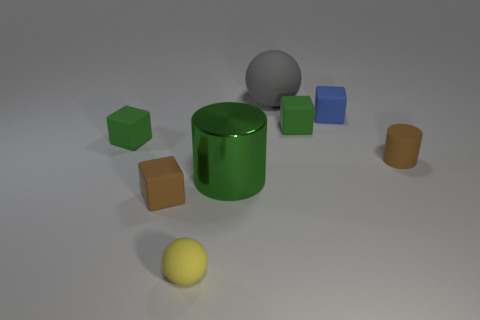Are there any other things that are the same shape as the tiny yellow object?
Your answer should be compact. Yes. How many green rubber objects are right of the big metal thing and left of the brown block?
Give a very brief answer. 0. Does the blue rubber block have the same size as the gray matte thing?
Provide a succinct answer. No. There is a green matte cube that is on the right side of the yellow rubber sphere; does it have the same size as the gray rubber thing?
Your response must be concise. No. What color is the block that is in front of the metal cylinder?
Provide a succinct answer. Brown. What number of green matte blocks are there?
Offer a very short reply. 2. There is a brown object that is made of the same material as the tiny brown cylinder; what is its shape?
Give a very brief answer. Cube. There is a tiny matte cube that is in front of the brown cylinder; is it the same color as the cylinder behind the green cylinder?
Provide a short and direct response. Yes. Are there the same number of tiny brown objects behind the tiny blue block and large gray shiny blocks?
Ensure brevity in your answer.  Yes. How many tiny objects are behind the tiny yellow object?
Provide a short and direct response. 5. 